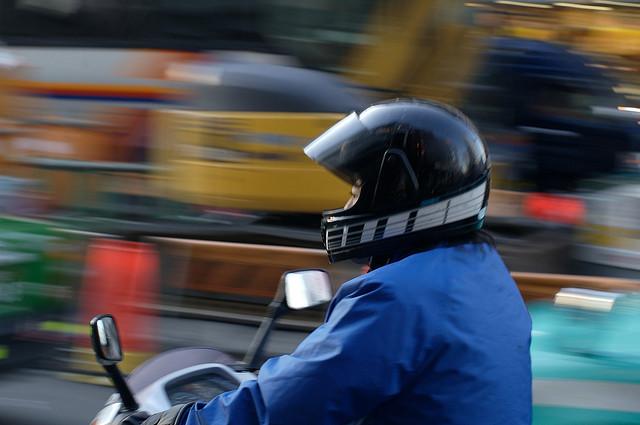What color is the jacket?
Write a very short answer. Blue. What object are people holding to protect themselves from rain?
Quick response, please. Umbrella. Is the person wearing a helmet?
Be succinct. Yes. How many mirrors in the photo?
Give a very brief answer. 2. 